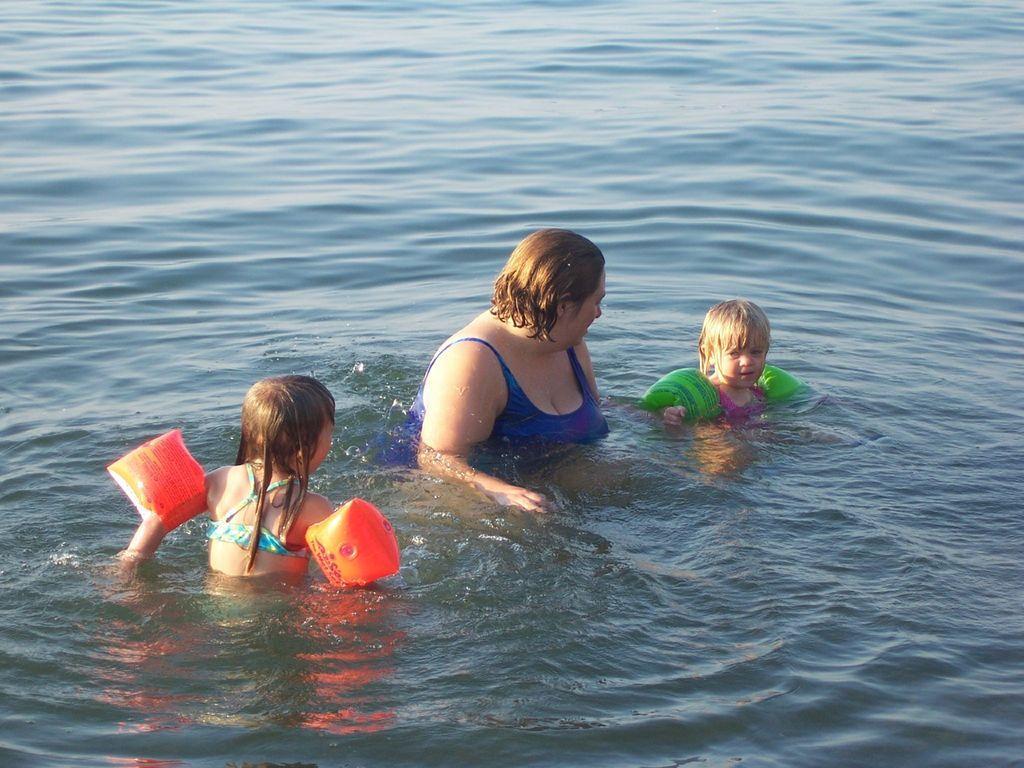Describe this image in one or two sentences. In this image I can see a woman and two children in the water. I can see the balloons to the children's hands. The woman is looking at the child who is on the right side. 